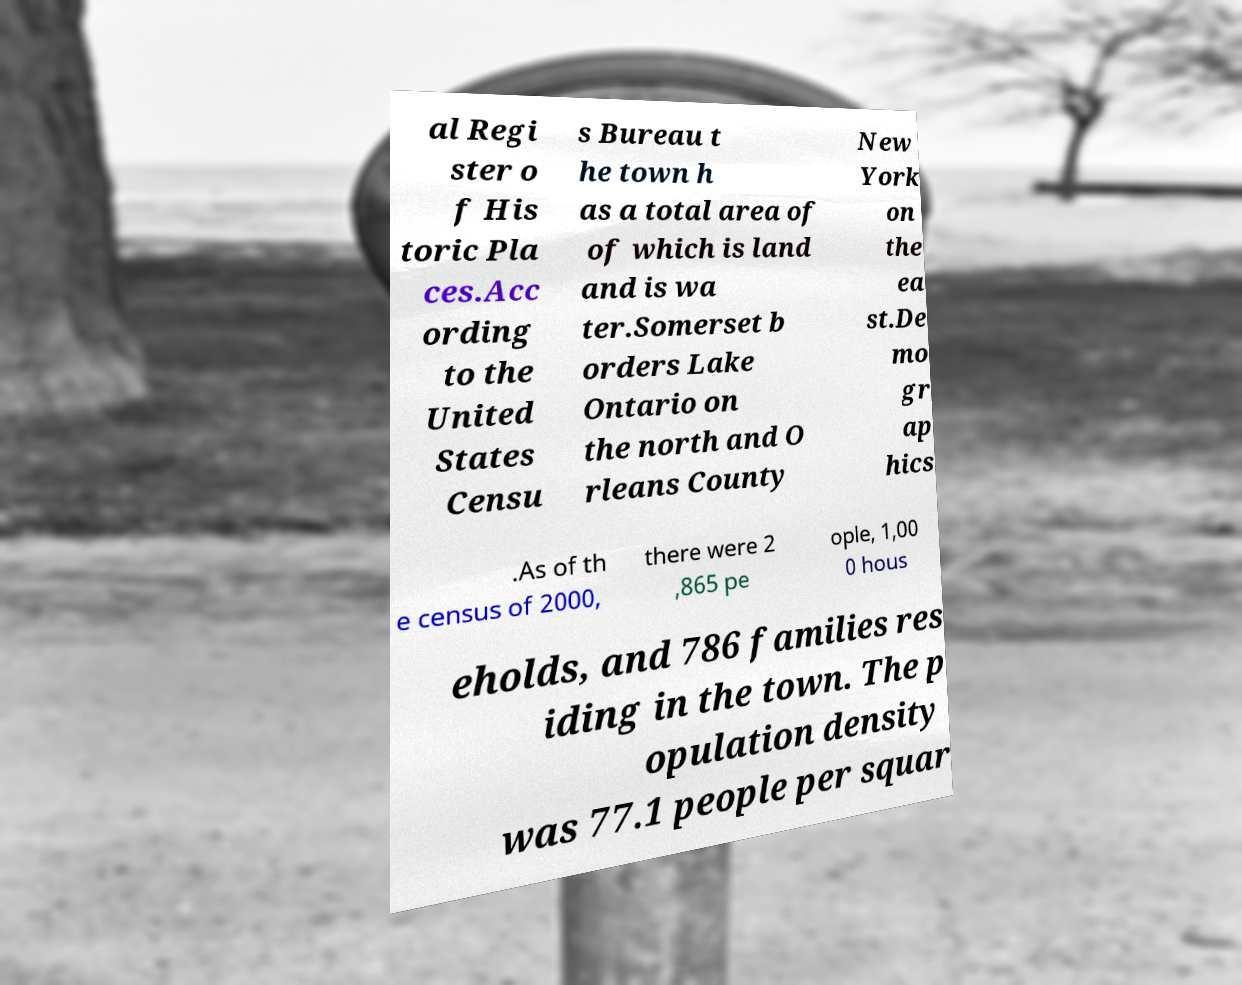For documentation purposes, I need the text within this image transcribed. Could you provide that? al Regi ster o f His toric Pla ces.Acc ording to the United States Censu s Bureau t he town h as a total area of of which is land and is wa ter.Somerset b orders Lake Ontario on the north and O rleans County New York on the ea st.De mo gr ap hics .As of th e census of 2000, there were 2 ,865 pe ople, 1,00 0 hous eholds, and 786 families res iding in the town. The p opulation density was 77.1 people per squar 